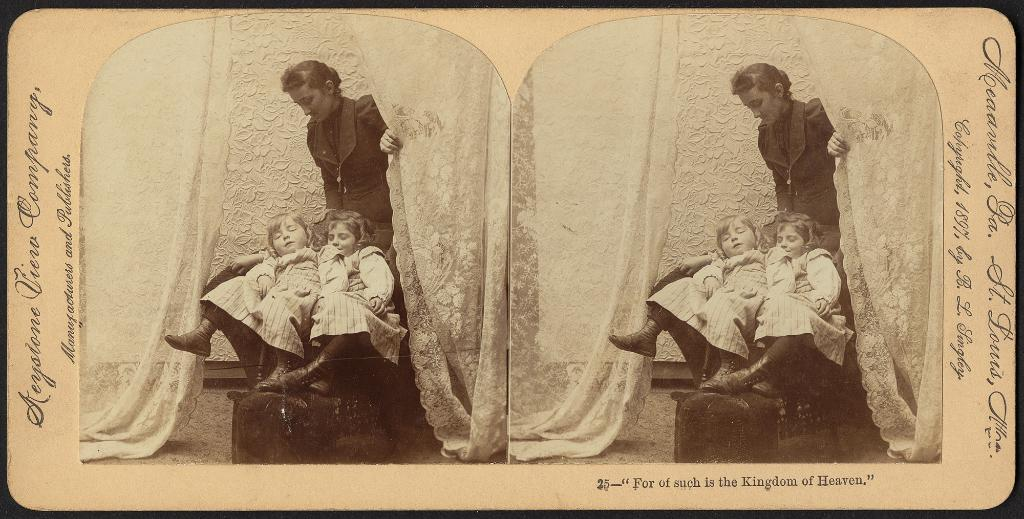What is the main subject of the image? The main subject of the image is a photo collage. How many people are featured in the photo collage? The photo collage contains pictures of three people. What else can be seen in the image besides the photo collage? There is text on a board in the image. What type of toys are being played with by the people in the image? There are no toys present in the image; it features a photo collage with pictures of three people and text on a board. 